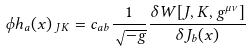Convert formula to latex. <formula><loc_0><loc_0><loc_500><loc_500>\phi h _ { a } ( x ) _ { \text { $JK$} } = c _ { a b } \frac { 1 } { \sqrt { - g } } \frac { \delta W [ J , K , g ^ { \mu \nu } ] } { \delta J _ { b } ( x ) }</formula> 